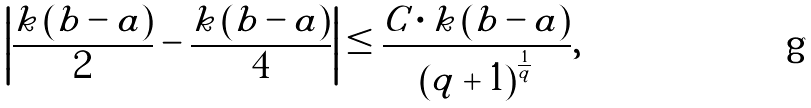<formula> <loc_0><loc_0><loc_500><loc_500>\left | \frac { k \left ( b - a \right ) } { 2 } - \frac { k \left ( b - a \right ) } { 4 } \right | \leq \frac { C \cdot k \left ( b - a \right ) } { \left ( q + 1 \right ) ^ { \frac { 1 } { q } } } ,</formula> 